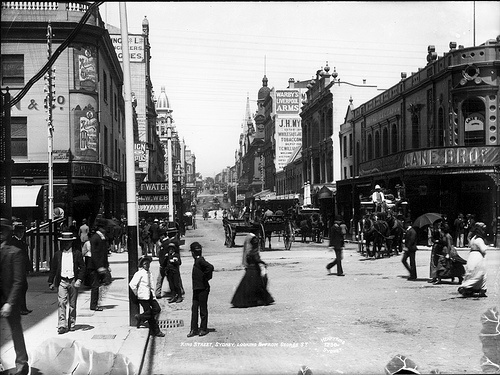Describe the objects in this image and their specific colors. I can see people in black, gray, darkgray, and lightgray tones, people in black, lightgray, gray, and darkgray tones, people in black, gray, darkgray, and lightgray tones, people in black, lightgray, darkgray, and gray tones, and people in black, gray, darkgray, and lightgray tones in this image. 